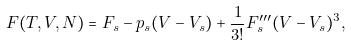Convert formula to latex. <formula><loc_0><loc_0><loc_500><loc_500>F ( T , V , N ) = F _ { s } - p _ { s } ( V - V _ { s } ) + \frac { 1 } { 3 ! } F _ { s } ^ { \prime \prime \prime } ( V - V _ { s } ) ^ { 3 } ,</formula> 